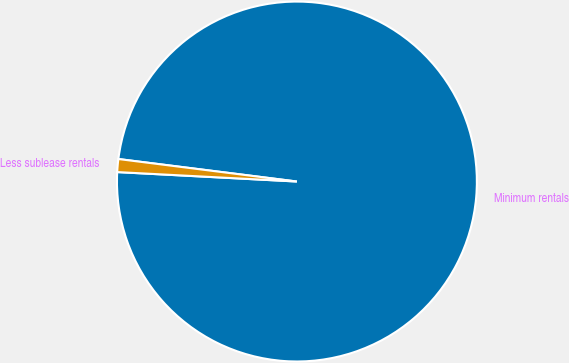Convert chart. <chart><loc_0><loc_0><loc_500><loc_500><pie_chart><fcel>Minimum rentals<fcel>Less sublease rentals<nl><fcel>98.84%<fcel>1.16%<nl></chart> 